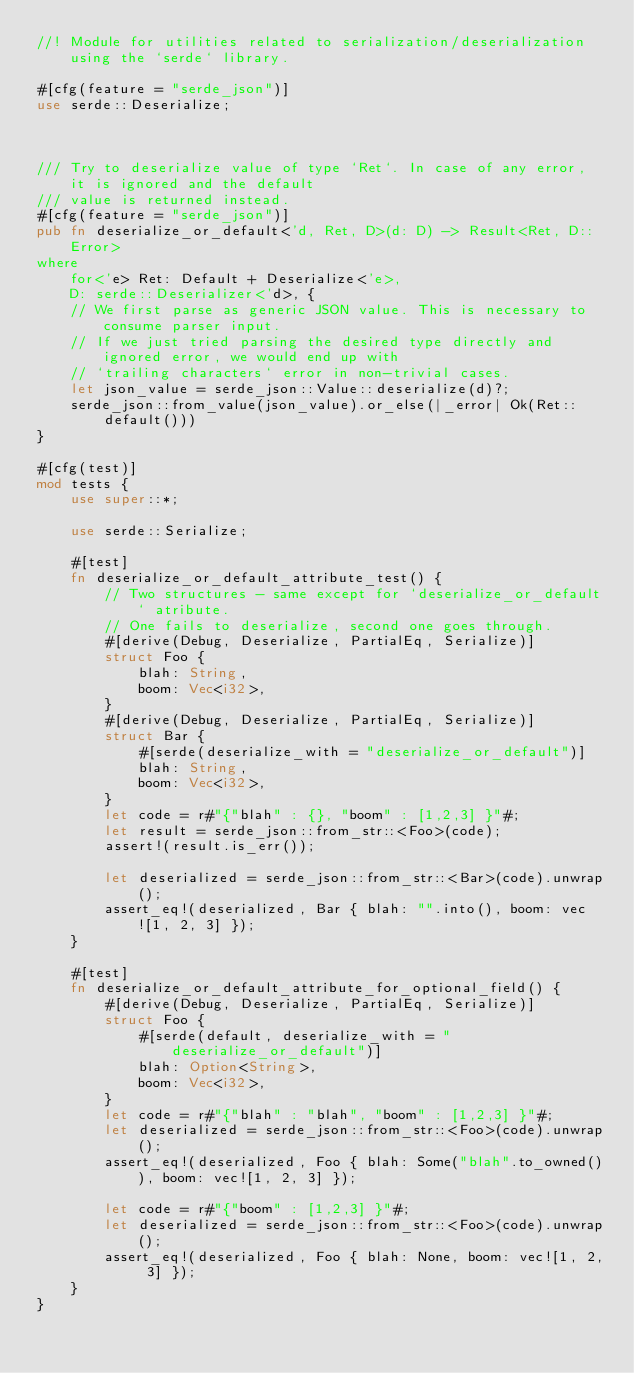Convert code to text. <code><loc_0><loc_0><loc_500><loc_500><_Rust_>//! Module for utilities related to serialization/deserialization using the `serde` library.

#[cfg(feature = "serde_json")]
use serde::Deserialize;



/// Try to deserialize value of type `Ret`. In case of any error, it is ignored and the default
/// value is returned instead.
#[cfg(feature = "serde_json")]
pub fn deserialize_or_default<'d, Ret, D>(d: D) -> Result<Ret, D::Error>
where
    for<'e> Ret: Default + Deserialize<'e>,
    D: serde::Deserializer<'d>, {
    // We first parse as generic JSON value. This is necessary to consume parser input.
    // If we just tried parsing the desired type directly and ignored error, we would end up with
    // `trailing characters` error in non-trivial cases.
    let json_value = serde_json::Value::deserialize(d)?;
    serde_json::from_value(json_value).or_else(|_error| Ok(Ret::default()))
}

#[cfg(test)]
mod tests {
    use super::*;

    use serde::Serialize;

    #[test]
    fn deserialize_or_default_attribute_test() {
        // Two structures - same except for `deserialize_or_default` atribute.
        // One fails to deserialize, second one goes through.
        #[derive(Debug, Deserialize, PartialEq, Serialize)]
        struct Foo {
            blah: String,
            boom: Vec<i32>,
        }
        #[derive(Debug, Deserialize, PartialEq, Serialize)]
        struct Bar {
            #[serde(deserialize_with = "deserialize_or_default")]
            blah: String,
            boom: Vec<i32>,
        }
        let code = r#"{"blah" : {}, "boom" : [1,2,3] }"#;
        let result = serde_json::from_str::<Foo>(code);
        assert!(result.is_err());

        let deserialized = serde_json::from_str::<Bar>(code).unwrap();
        assert_eq!(deserialized, Bar { blah: "".into(), boom: vec![1, 2, 3] });
    }

    #[test]
    fn deserialize_or_default_attribute_for_optional_field() {
        #[derive(Debug, Deserialize, PartialEq, Serialize)]
        struct Foo {
            #[serde(default, deserialize_with = "deserialize_or_default")]
            blah: Option<String>,
            boom: Vec<i32>,
        }
        let code = r#"{"blah" : "blah", "boom" : [1,2,3] }"#;
        let deserialized = serde_json::from_str::<Foo>(code).unwrap();
        assert_eq!(deserialized, Foo { blah: Some("blah".to_owned()), boom: vec![1, 2, 3] });

        let code = r#"{"boom" : [1,2,3] }"#;
        let deserialized = serde_json::from_str::<Foo>(code).unwrap();
        assert_eq!(deserialized, Foo { blah: None, boom: vec![1, 2, 3] });
    }
}
</code> 